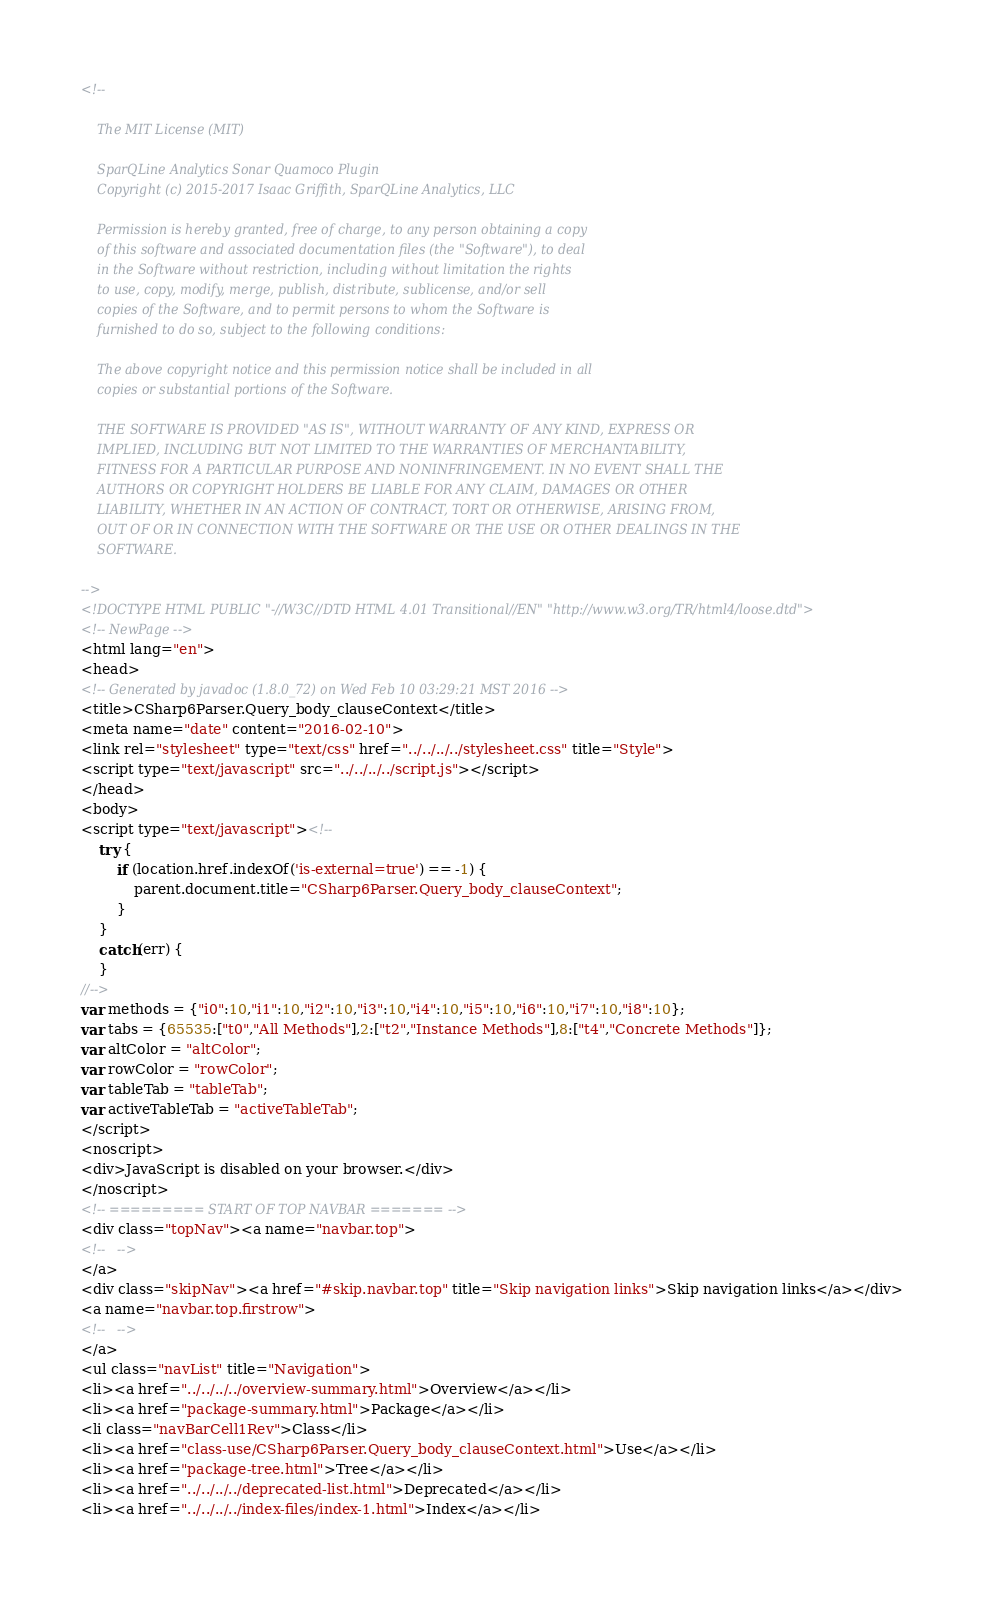<code> <loc_0><loc_0><loc_500><loc_500><_HTML_><!--

    The MIT License (MIT)

    SparQLine Analytics Sonar Quamoco Plugin
    Copyright (c) 2015-2017 Isaac Griffith, SparQLine Analytics, LLC

    Permission is hereby granted, free of charge, to any person obtaining a copy
    of this software and associated documentation files (the "Software"), to deal
    in the Software without restriction, including without limitation the rights
    to use, copy, modify, merge, publish, distribute, sublicense, and/or sell
    copies of the Software, and to permit persons to whom the Software is
    furnished to do so, subject to the following conditions:

    The above copyright notice and this permission notice shall be included in all
    copies or substantial portions of the Software.

    THE SOFTWARE IS PROVIDED "AS IS", WITHOUT WARRANTY OF ANY KIND, EXPRESS OR
    IMPLIED, INCLUDING BUT NOT LIMITED TO THE WARRANTIES OF MERCHANTABILITY,
    FITNESS FOR A PARTICULAR PURPOSE AND NONINFRINGEMENT. IN NO EVENT SHALL THE
    AUTHORS OR COPYRIGHT HOLDERS BE LIABLE FOR ANY CLAIM, DAMAGES OR OTHER
    LIABILITY, WHETHER IN AN ACTION OF CONTRACT, TORT OR OTHERWISE, ARISING FROM,
    OUT OF OR IN CONNECTION WITH THE SOFTWARE OR THE USE OR OTHER DEALINGS IN THE
    SOFTWARE.

-->
<!DOCTYPE HTML PUBLIC "-//W3C//DTD HTML 4.01 Transitional//EN" "http://www.w3.org/TR/html4/loose.dtd">
<!-- NewPage -->
<html lang="en">
<head>
<!-- Generated by javadoc (1.8.0_72) on Wed Feb 10 03:29:21 MST 2016 -->
<title>CSharp6Parser.Query_body_clauseContext</title>
<meta name="date" content="2016-02-10">
<link rel="stylesheet" type="text/css" href="../../../../stylesheet.css" title="Style">
<script type="text/javascript" src="../../../../script.js"></script>
</head>
<body>
<script type="text/javascript"><!--
    try {
        if (location.href.indexOf('is-external=true') == -1) {
            parent.document.title="CSharp6Parser.Query_body_clauseContext";
        }
    }
    catch(err) {
    }
//-->
var methods = {"i0":10,"i1":10,"i2":10,"i3":10,"i4":10,"i5":10,"i6":10,"i7":10,"i8":10};
var tabs = {65535:["t0","All Methods"],2:["t2","Instance Methods"],8:["t4","Concrete Methods"]};
var altColor = "altColor";
var rowColor = "rowColor";
var tableTab = "tableTab";
var activeTableTab = "activeTableTab";
</script>
<noscript>
<div>JavaScript is disabled on your browser.</div>
</noscript>
<!-- ========= START OF TOP NAVBAR ======= -->
<div class="topNav"><a name="navbar.top">
<!--   -->
</a>
<div class="skipNav"><a href="#skip.navbar.top" title="Skip navigation links">Skip navigation links</a></div>
<a name="navbar.top.firstrow">
<!--   -->
</a>
<ul class="navList" title="Navigation">
<li><a href="../../../../overview-summary.html">Overview</a></li>
<li><a href="package-summary.html">Package</a></li>
<li class="navBarCell1Rev">Class</li>
<li><a href="class-use/CSharp6Parser.Query_body_clauseContext.html">Use</a></li>
<li><a href="package-tree.html">Tree</a></li>
<li><a href="../../../../deprecated-list.html">Deprecated</a></li>
<li><a href="../../../../index-files/index-1.html">Index</a></li></code> 